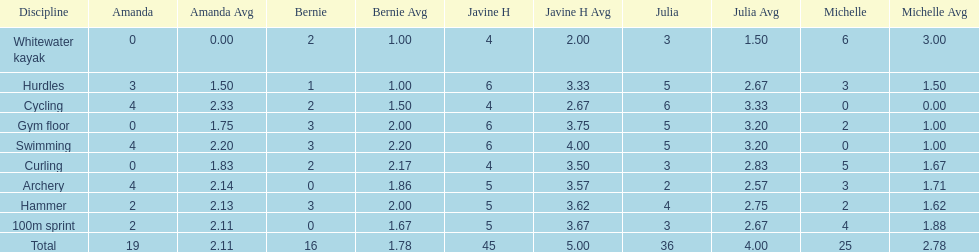What other girl besides amanda also had a 4 in cycling? Javine H. 